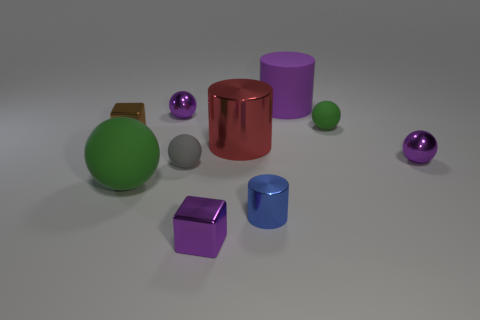How big is the purple block?
Make the answer very short. Small. There is a matte sphere on the right side of the small purple metal cube; is it the same color as the big object in front of the big metallic object?
Offer a very short reply. Yes. How many other objects are the same material as the small green sphere?
Your answer should be very brief. 3. Is there a red rubber block?
Offer a terse response. No. Does the green object to the right of the purple shiny block have the same material as the tiny brown thing?
Give a very brief answer. No. There is another tiny object that is the same shape as the brown metallic object; what is its material?
Provide a short and direct response. Metal. There is a tiny block that is the same color as the large rubber cylinder; what is it made of?
Give a very brief answer. Metal. Is the number of purple rubber objects less than the number of big objects?
Your answer should be compact. Yes. There is a small shiny sphere to the left of the gray sphere; does it have the same color as the big matte cylinder?
Provide a succinct answer. Yes. There is a cylinder that is the same material as the big ball; what color is it?
Your answer should be very brief. Purple. 